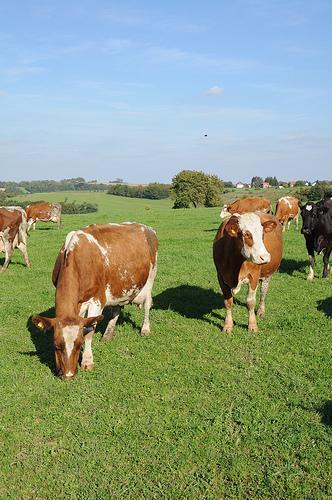How many black cows are visible?
Give a very brief answer. 1. 